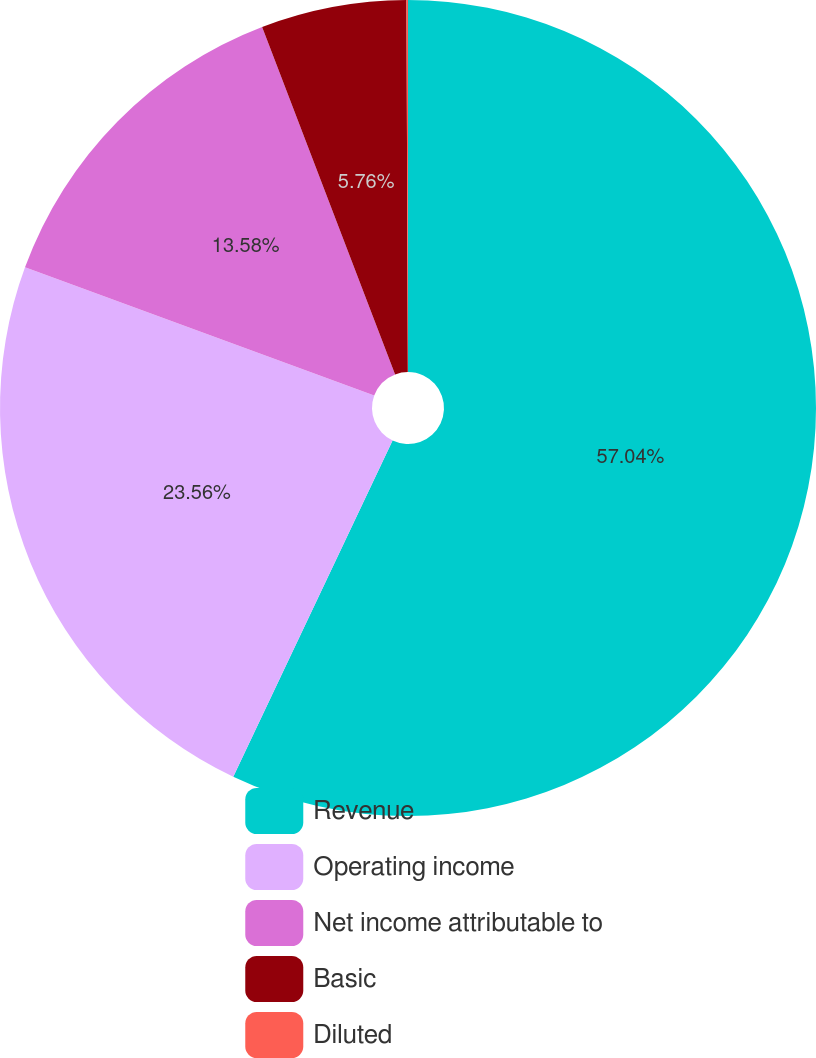Convert chart to OTSL. <chart><loc_0><loc_0><loc_500><loc_500><pie_chart><fcel>Revenue<fcel>Operating income<fcel>Net income attributable to<fcel>Basic<fcel>Diluted<nl><fcel>57.05%<fcel>23.56%<fcel>13.58%<fcel>5.76%<fcel>0.06%<nl></chart> 